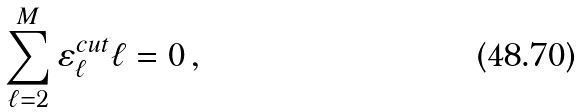Convert formula to latex. <formula><loc_0><loc_0><loc_500><loc_500>\sum _ { \ell = 2 } ^ { M } \varepsilon _ { \ell } ^ { c u t } \ell = 0 \, ,</formula> 